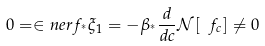<formula> <loc_0><loc_0><loc_500><loc_500>0 = \in n e r { f _ { ^ { * } } } { \xi _ { 1 } } = - \beta _ { ^ { * } } \frac { d } { d c } \mathcal { N } [ \ f _ { c } ] \neq 0</formula> 